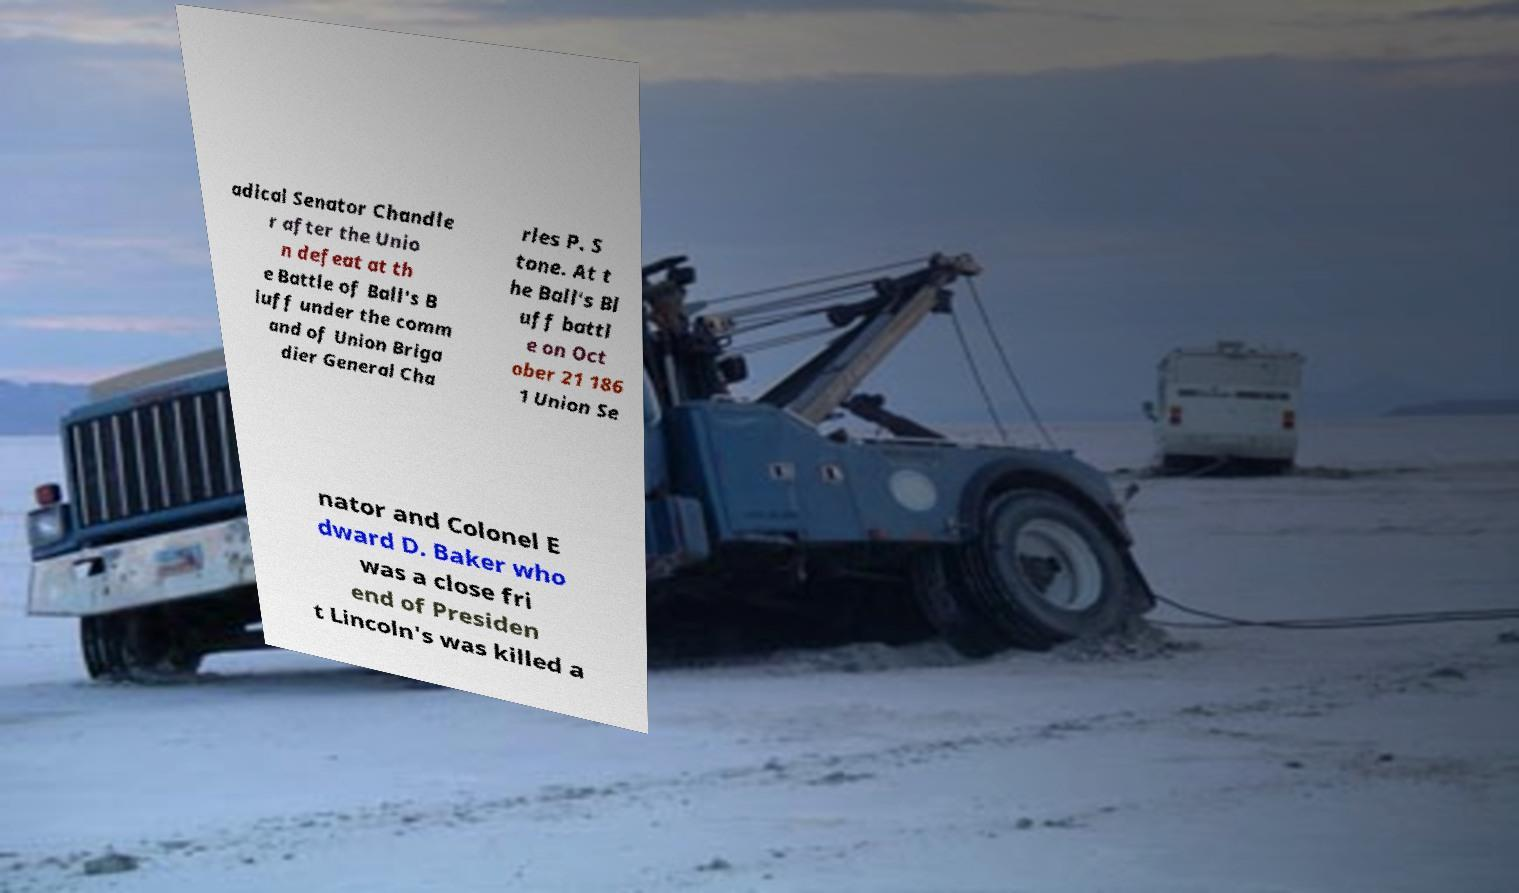Can you accurately transcribe the text from the provided image for me? adical Senator Chandle r after the Unio n defeat at th e Battle of Ball's B luff under the comm and of Union Briga dier General Cha rles P. S tone. At t he Ball's Bl uff battl e on Oct ober 21 186 1 Union Se nator and Colonel E dward D. Baker who was a close fri end of Presiden t Lincoln's was killed a 